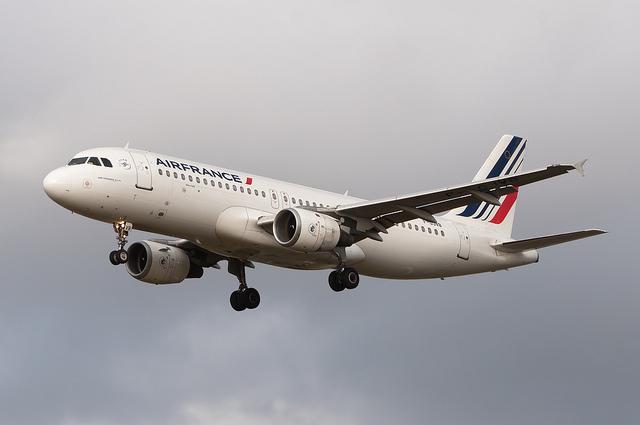Is the plane taking off?
Short answer required. Yes. Is the landing gear down?
Concise answer only. Yes. What airline is the plane from?
Concise answer only. Air france. What color is the sky?
Give a very brief answer. Gray. What is written on the plane?
Short answer required. Air france. What is the word on the side of the plane?
Quick response, please. Air france. What color are the engines?
Short answer required. White. What is the name of the airline?
Write a very short answer. Air france. Which airline does the plane belong to?
Give a very brief answer. Air france. 